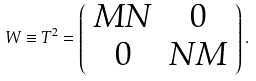<formula> <loc_0><loc_0><loc_500><loc_500>W \equiv T ^ { 2 } = \left ( \begin{array} { c c } M N & 0 \\ 0 & N M \end{array} \right ) .</formula> 